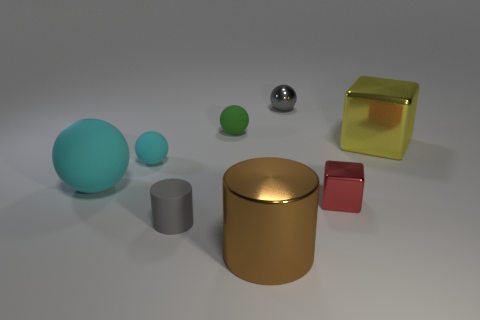Are there any reflections visible on the surfaces? Yes, there are noticeable reflections on some of the objects. The metallic sphere has a clear reflection of the environment, and the glass-like surfaces of the cube and cuboid show subtle reflections and light distortions. Does the lighting have a specific direction? The lighting appears to come from the upper left side, which creates soft shadows on the right side of the objects, giving the scene a sense of depth and dimensionality. 